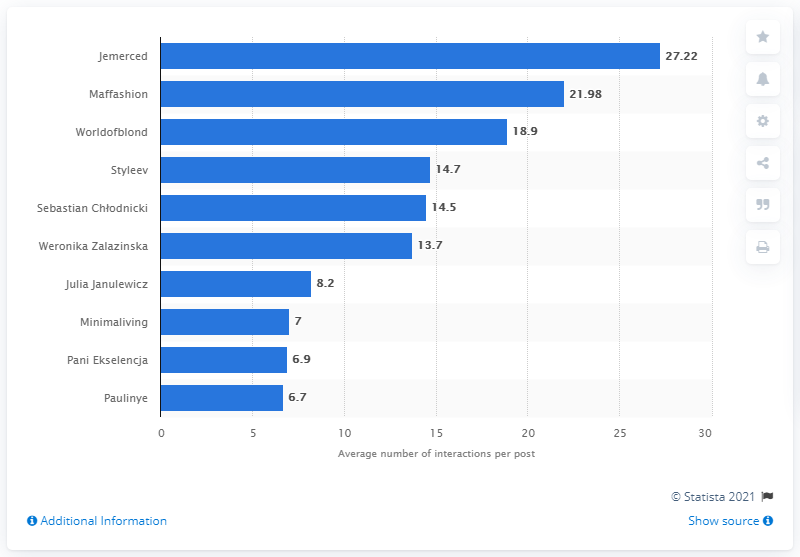Highlight a few significant elements in this photo. Jessica Mercedes Kirschner was known by the nickname "Jemerced. 